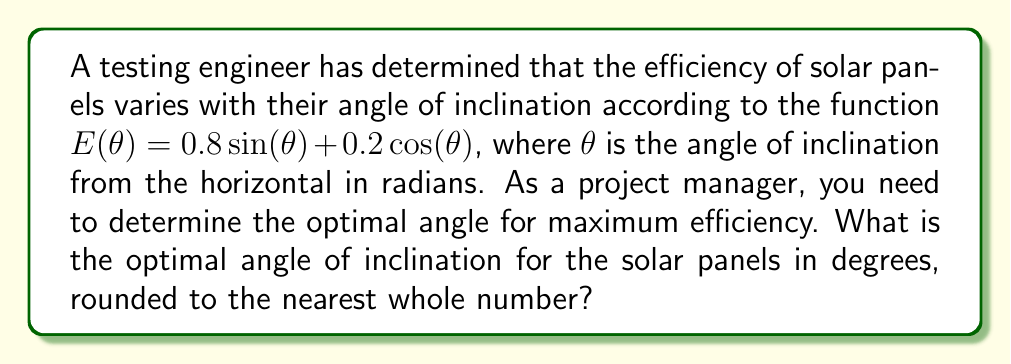Could you help me with this problem? To find the optimal angle, we need to maximize the efficiency function $E(\theta)$. This can be done by finding the derivative and setting it to zero.

1) First, let's find the derivative of $E(\theta)$:
   $$E'(\theta) = 0.8 \cos(\theta) - 0.2\sin(\theta)$$

2) Set the derivative to zero:
   $$0.8 \cos(\theta) - 0.2\sin(\theta) = 0$$

3) Divide both sides by $\cos(\theta)$ (assuming $\cos(\theta) \neq 0$):
   $$0.8 - 0.2\tan(\theta) = 0$$

4) Solve for $\tan(\theta)$:
   $$\tan(\theta) = 4$$

5) Take the inverse tangent (arctangent) of both sides:
   $$\theta = \arctan(4)$$

6) Convert to degrees:
   $$\theta = \arctan(4) \cdot \frac{180}{\pi} \approx 75.96°$$

7) Round to the nearest whole number:
   $$\theta \approx 76°$$

Therefore, the optimal angle of inclination for the solar panels is approximately 76°.
Answer: 76° 